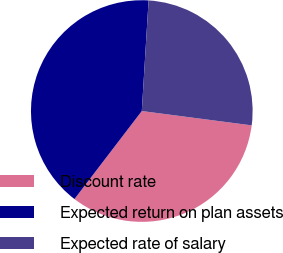<chart> <loc_0><loc_0><loc_500><loc_500><pie_chart><fcel>Discount rate<fcel>Expected return on plan assets<fcel>Expected rate of salary<nl><fcel>33.33%<fcel>40.58%<fcel>26.09%<nl></chart> 